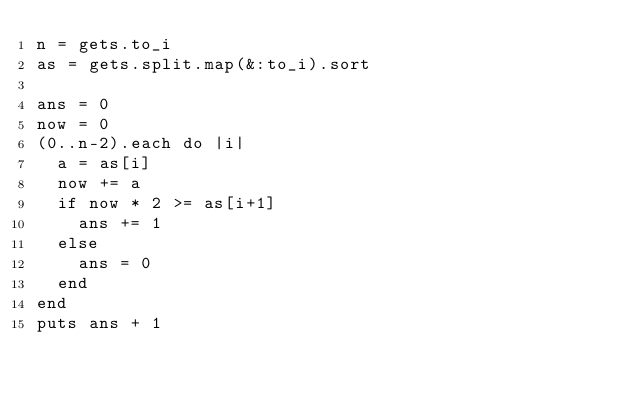<code> <loc_0><loc_0><loc_500><loc_500><_Ruby_>n = gets.to_i
as = gets.split.map(&:to_i).sort

ans = 0
now = 0
(0..n-2).each do |i|
  a = as[i]
  now += a
  if now * 2 >= as[i+1]
    ans += 1
  else
    ans = 0
  end
end
puts ans + 1
</code> 